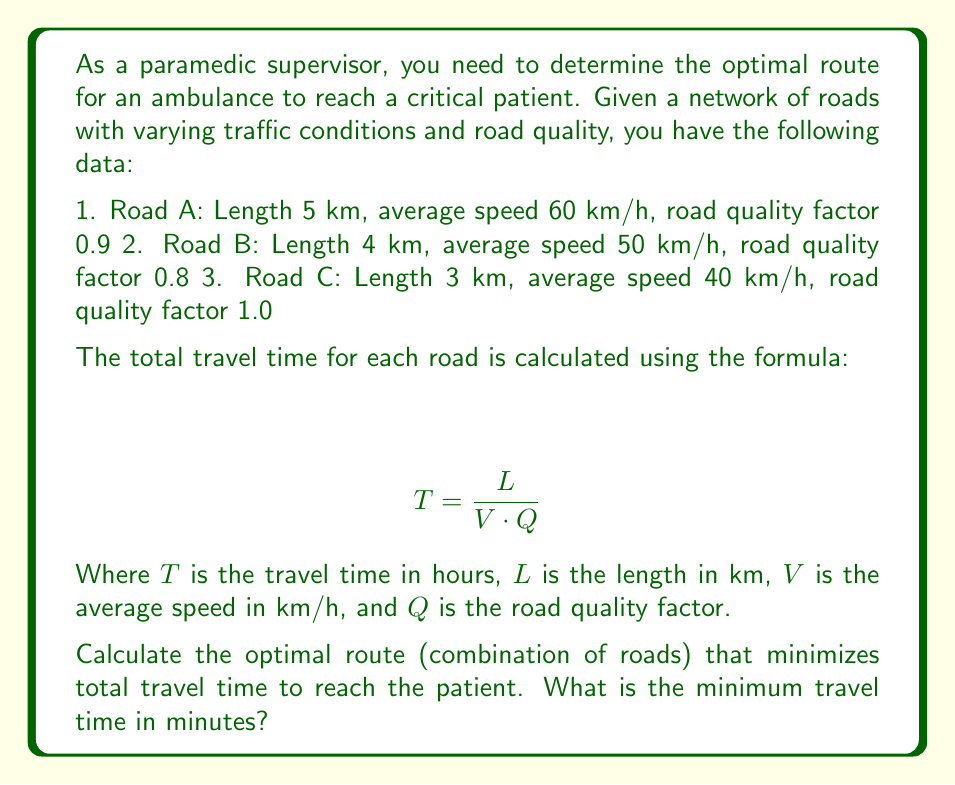What is the answer to this math problem? To solve this inverse problem and determine the optimal route, we need to calculate the travel time for each road and then consider all possible combinations to find the minimum total time.

Step 1: Calculate travel time for each road

Road A:
$$ T_A = \frac{5}{60 \cdot 0.9} = 0.0926 \text{ hours} $$

Road B:
$$ T_B = \frac{4}{50 \cdot 0.8} = 0.1000 \text{ hours} $$

Road C:
$$ T_C = \frac{3}{40 \cdot 1.0} = 0.0750 \text{ hours} $$

Step 2: Consider all possible combinations of roads

1. A + B: $0.0926 + 0.1000 = 0.1926 \text{ hours}$
2. A + C: $0.0926 + 0.0750 = 0.1676 \text{ hours}$
3. B + C: $0.1000 + 0.0750 = 0.1750 \text{ hours}$

Step 3: Identify the minimum travel time

The minimum travel time is achieved by combining roads A and C: 0.1676 hours

Step 4: Convert the minimum travel time to minutes

$$ 0.1676 \text{ hours} \times 60 \text{ minutes/hour} = 10.056 \text{ minutes} $$

Therefore, the optimal route is to take Road A followed by Road C, with a total travel time of approximately 10.06 minutes.
Answer: 10.06 minutes 